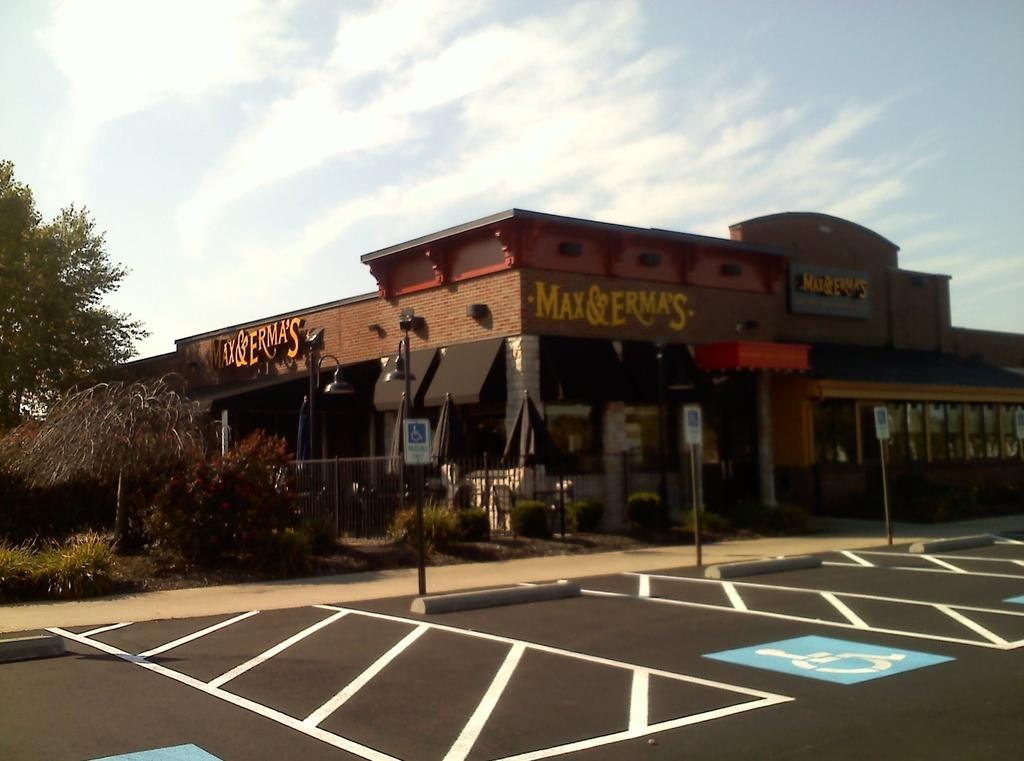What type of structures can be seen in the image? There are boards, poles, a fence, and buildings visible in the image. What type of natural elements can be seen in the image? There is grass, plants, trees, and the sky visible in the image. Can you describe the group of people in the image? There is a group of people present in the image. What time of day was the image likely taken? The image was likely taken during the day, as the sky is visible. What type of poison is being used by the actor in the image? There is no actor or poison present in the image. What type of weather can be seen in the image? The image does not show any specific weather conditions; it only shows the sky. 